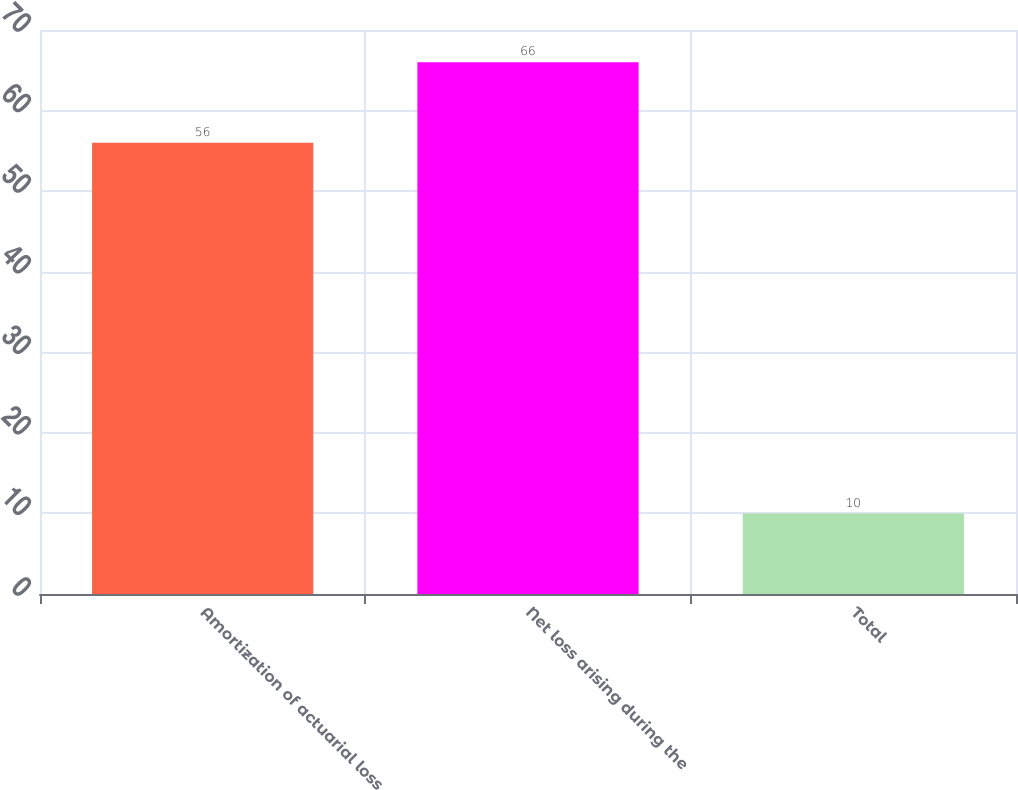Convert chart. <chart><loc_0><loc_0><loc_500><loc_500><bar_chart><fcel>Amortization of actuarial loss<fcel>Net loss arising during the<fcel>Total<nl><fcel>56<fcel>66<fcel>10<nl></chart> 